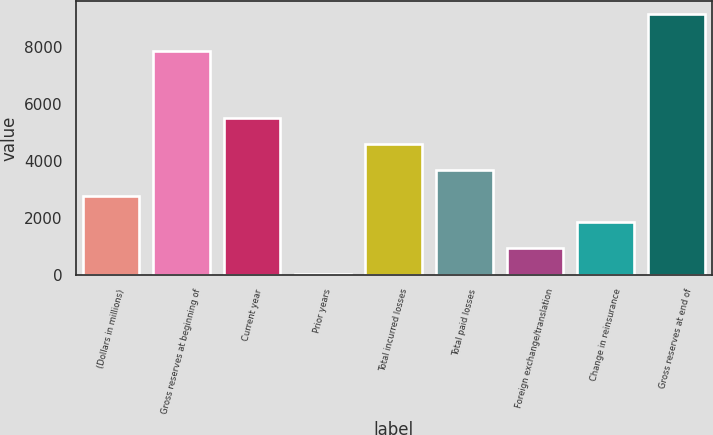<chart> <loc_0><loc_0><loc_500><loc_500><bar_chart><fcel>(Dollars in millions)<fcel>Gross reserves at beginning of<fcel>Current year<fcel>Prior years<fcel>Total incurred losses<fcel>Total paid losses<fcel>Foreign exchange/translation<fcel>Change in reinsurance<fcel>Gross reserves at end of<nl><fcel>2756.49<fcel>7836.3<fcel>5486.58<fcel>26.4<fcel>4576.55<fcel>3666.52<fcel>936.43<fcel>1846.46<fcel>9126.7<nl></chart> 